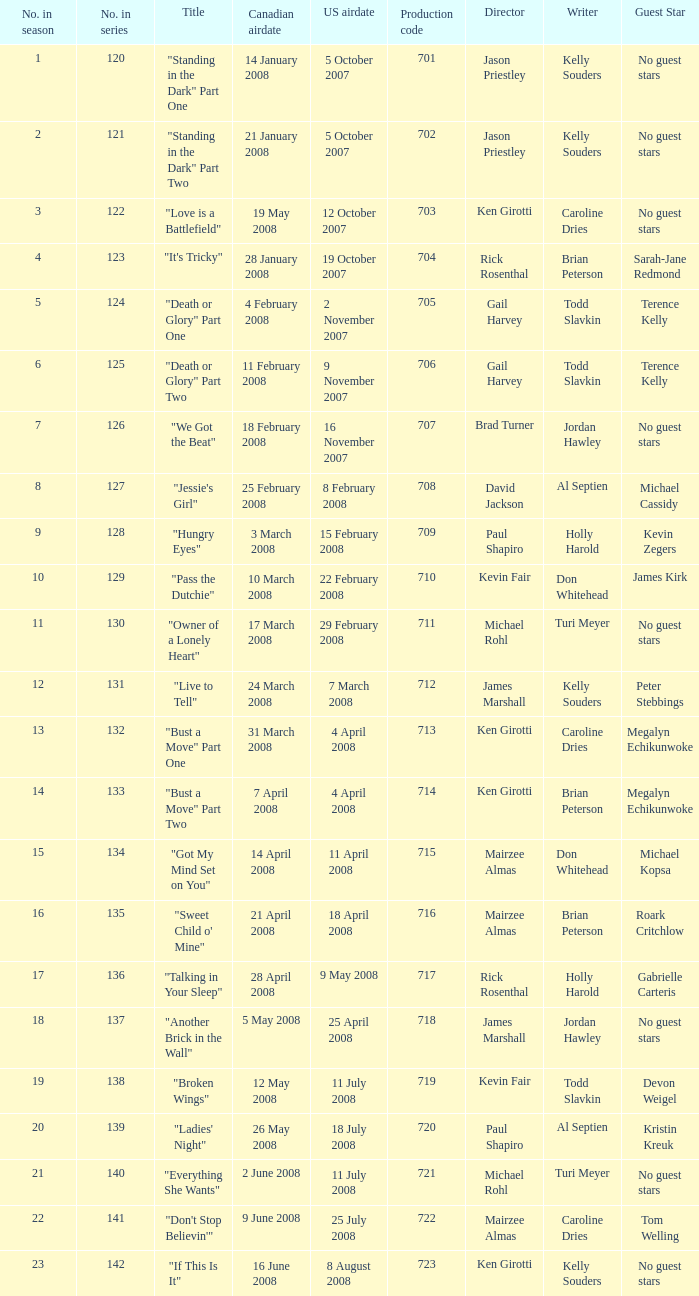The U.S. airdate of 4 april 2008 had a production code of what? 714.0. 